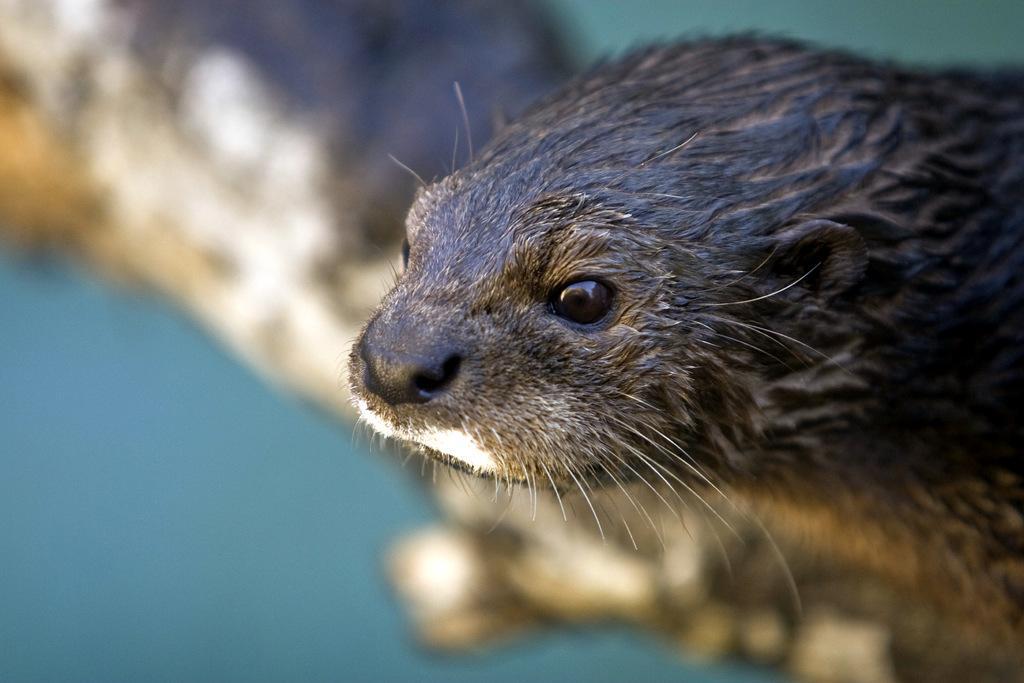How would you summarize this image in a sentence or two? This is the zoom-in picture of face of an animal which is in black color. 